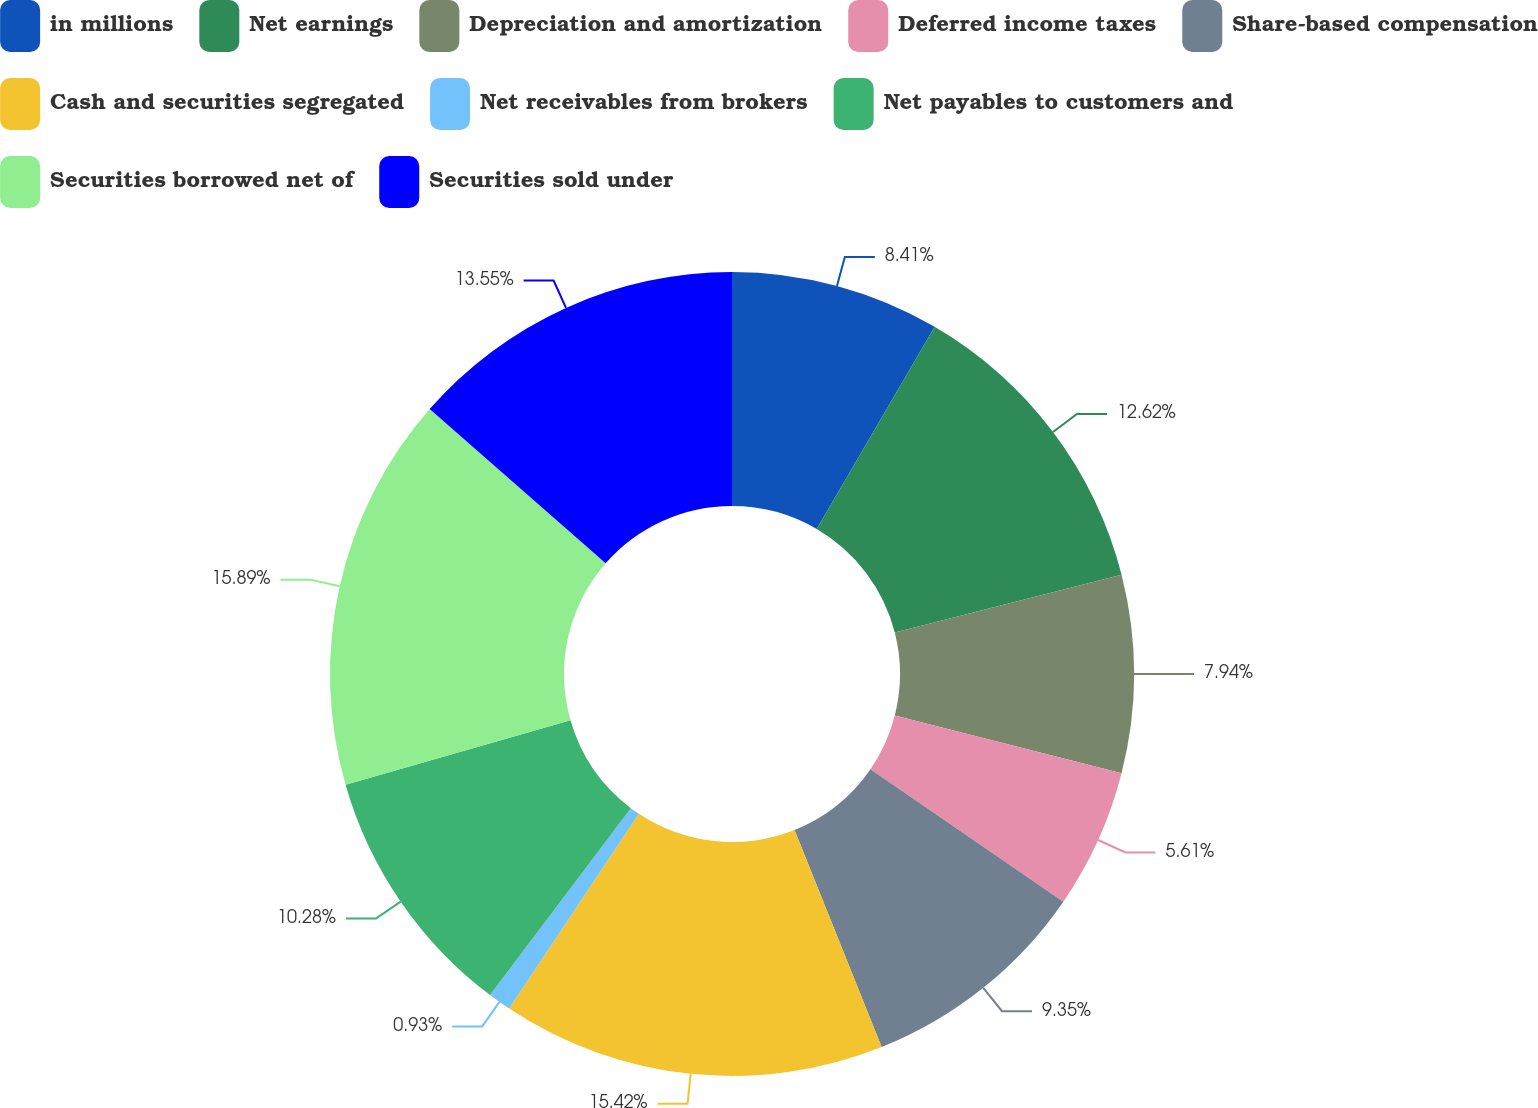Convert chart. <chart><loc_0><loc_0><loc_500><loc_500><pie_chart><fcel>in millions<fcel>Net earnings<fcel>Depreciation and amortization<fcel>Deferred income taxes<fcel>Share-based compensation<fcel>Cash and securities segregated<fcel>Net receivables from brokers<fcel>Net payables to customers and<fcel>Securities borrowed net of<fcel>Securities sold under<nl><fcel>8.41%<fcel>12.62%<fcel>7.94%<fcel>5.61%<fcel>9.35%<fcel>15.42%<fcel>0.93%<fcel>10.28%<fcel>15.89%<fcel>13.55%<nl></chart> 